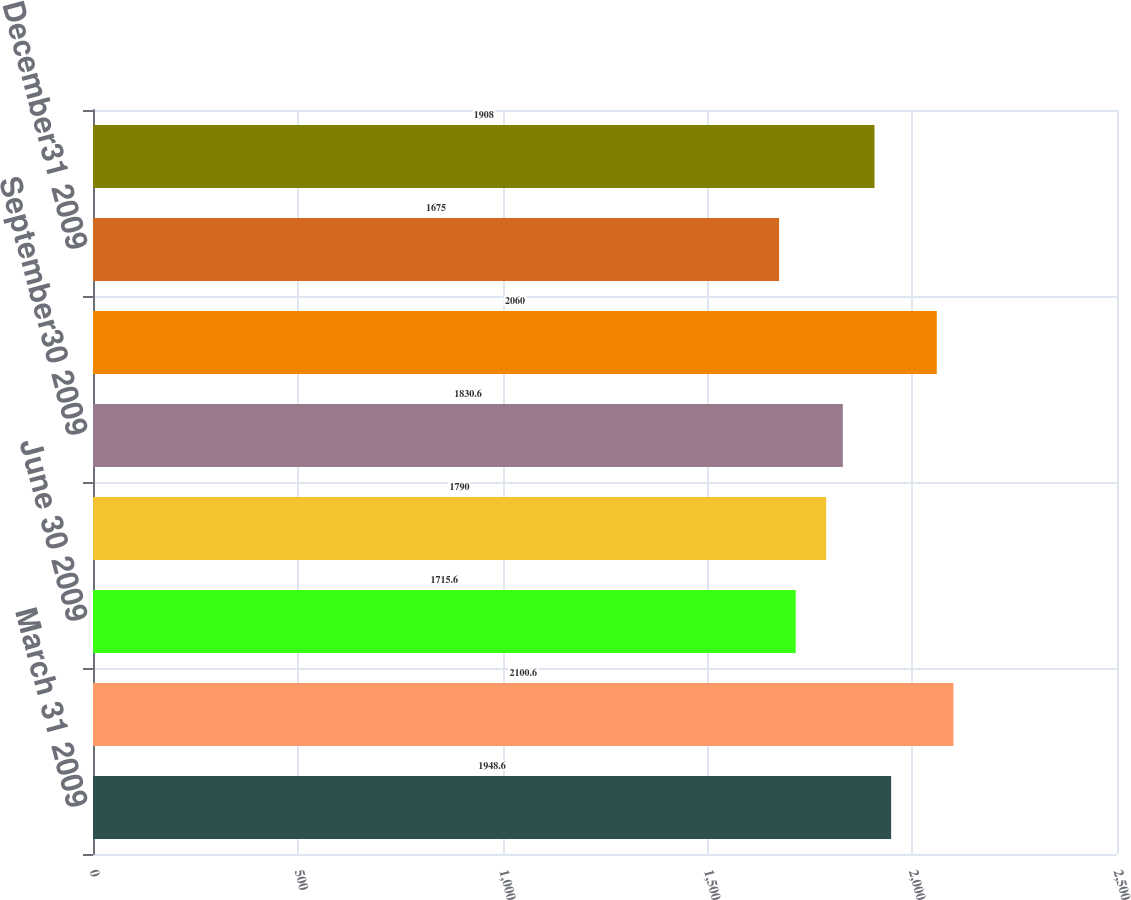Convert chart to OTSL. <chart><loc_0><loc_0><loc_500><loc_500><bar_chart><fcel>March 31 2009<fcel>March 31 2008<fcel>June 30 2009<fcel>June 30 2008<fcel>September30 2009<fcel>September30 2008<fcel>December31 2009<fcel>December31 2008<nl><fcel>1948.6<fcel>2100.6<fcel>1715.6<fcel>1790<fcel>1830.6<fcel>2060<fcel>1675<fcel>1908<nl></chart> 